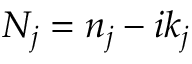Convert formula to latex. <formula><loc_0><loc_0><loc_500><loc_500>N _ { j } = n _ { j } - i k _ { j }</formula> 